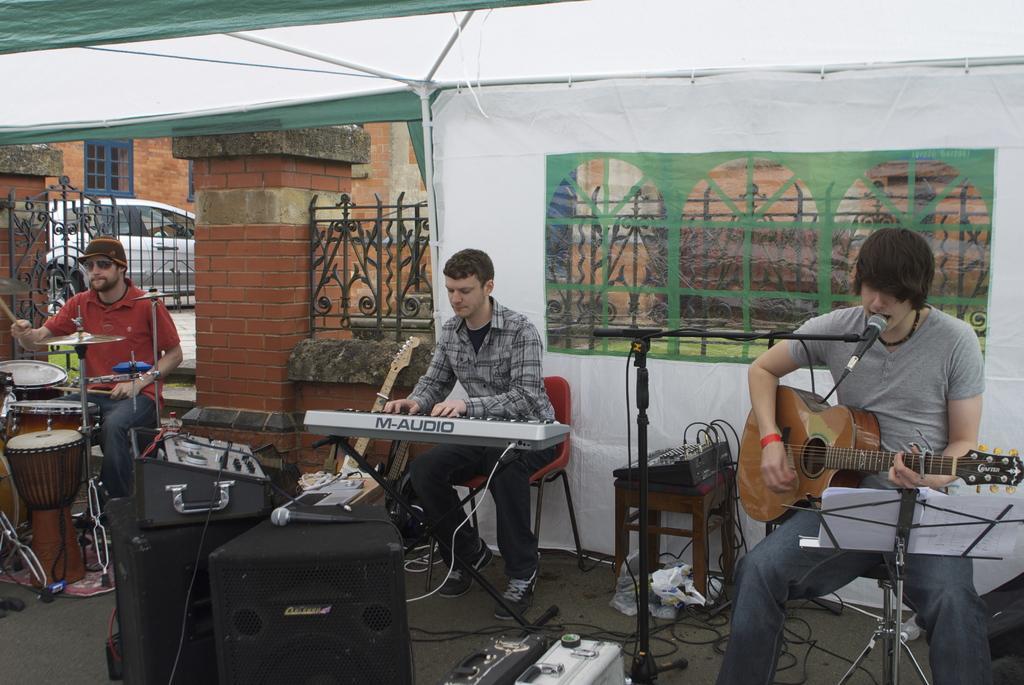Please provide a concise description of this image. The image looks like it is clicked on the roads under the tent. There are three persons in this image. To the left the man wearing red shirt is playing drums. In the middle, the man playing piano. To the right, the man is playing guitar. In front of the image, there are speakers, boxes. At the top, there is a tent. In the background, there is a car, building and red colored brick brick wall. 